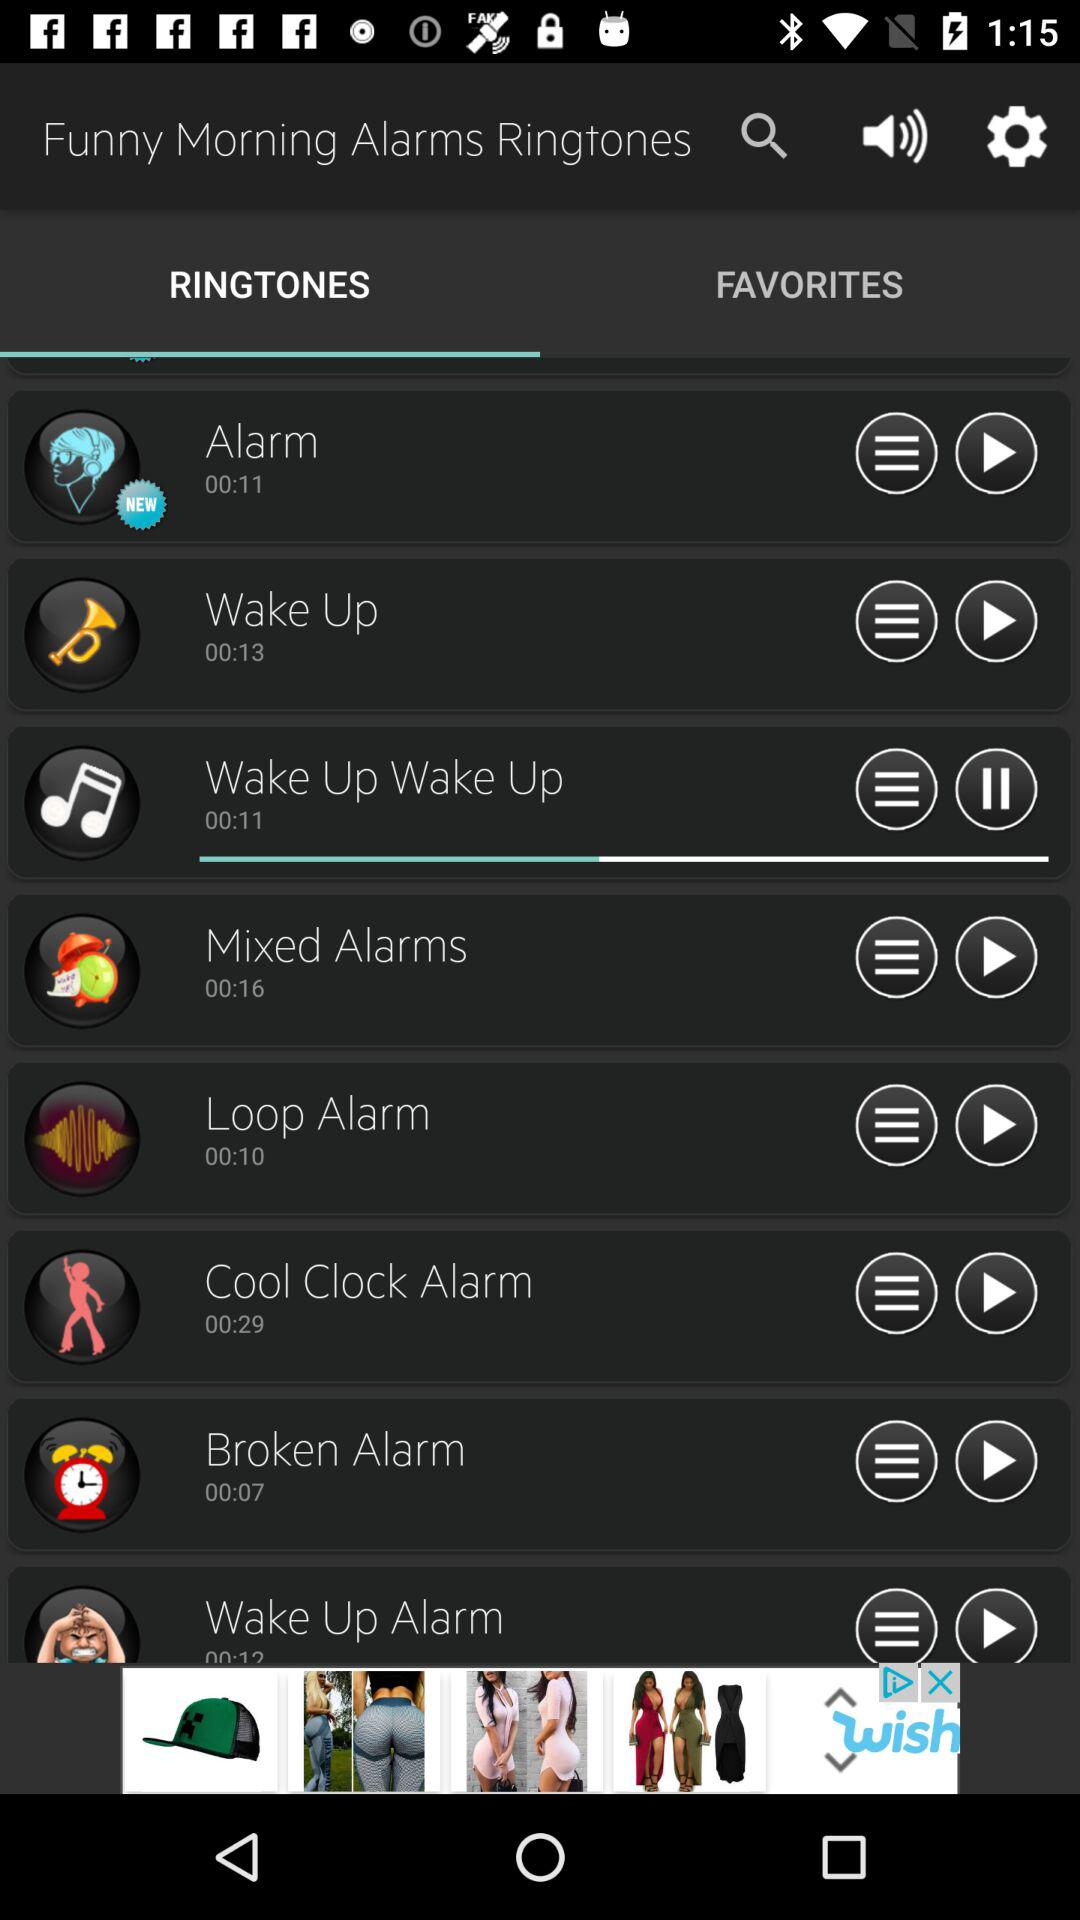What is the duration of the loop alarm? The duration is 10 seconds. 